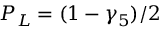Convert formula to latex. <formula><loc_0><loc_0><loc_500><loc_500>P _ { L } = ( 1 - \gamma _ { 5 } ) / 2</formula> 